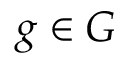Convert formula to latex. <formula><loc_0><loc_0><loc_500><loc_500>g \in G</formula> 